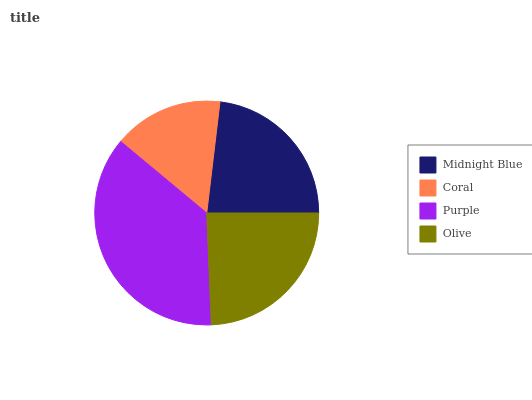Is Coral the minimum?
Answer yes or no. Yes. Is Purple the maximum?
Answer yes or no. Yes. Is Purple the minimum?
Answer yes or no. No. Is Coral the maximum?
Answer yes or no. No. Is Purple greater than Coral?
Answer yes or no. Yes. Is Coral less than Purple?
Answer yes or no. Yes. Is Coral greater than Purple?
Answer yes or no. No. Is Purple less than Coral?
Answer yes or no. No. Is Olive the high median?
Answer yes or no. Yes. Is Midnight Blue the low median?
Answer yes or no. Yes. Is Coral the high median?
Answer yes or no. No. Is Olive the low median?
Answer yes or no. No. 